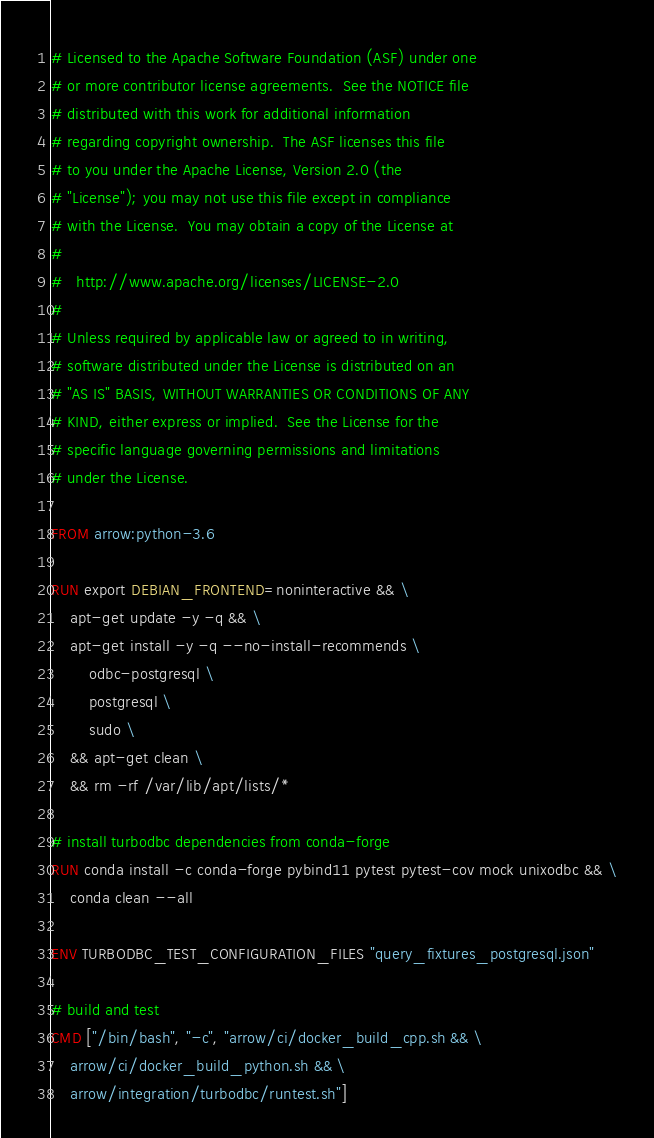<code> <loc_0><loc_0><loc_500><loc_500><_Dockerfile_># Licensed to the Apache Software Foundation (ASF) under one
# or more contributor license agreements.  See the NOTICE file
# distributed with this work for additional information
# regarding copyright ownership.  The ASF licenses this file
# to you under the Apache License, Version 2.0 (the
# "License"); you may not use this file except in compliance
# with the License.  You may obtain a copy of the License at
#
#   http://www.apache.org/licenses/LICENSE-2.0
#
# Unless required by applicable law or agreed to in writing,
# software distributed under the License is distributed on an
# "AS IS" BASIS, WITHOUT WARRANTIES OR CONDITIONS OF ANY
# KIND, either express or implied.  See the License for the
# specific language governing permissions and limitations
# under the License.

FROM arrow:python-3.6

RUN export DEBIAN_FRONTEND=noninteractive && \
    apt-get update -y -q && \
    apt-get install -y -q --no-install-recommends \
        odbc-postgresql \
        postgresql \
        sudo \
    && apt-get clean \
    && rm -rf /var/lib/apt/lists/*

# install turbodbc dependencies from conda-forge
RUN conda install -c conda-forge pybind11 pytest pytest-cov mock unixodbc && \
    conda clean --all

ENV TURBODBC_TEST_CONFIGURATION_FILES "query_fixtures_postgresql.json"

# build and test
CMD ["/bin/bash", "-c", "arrow/ci/docker_build_cpp.sh && \
    arrow/ci/docker_build_python.sh && \
    arrow/integration/turbodbc/runtest.sh"]
</code> 